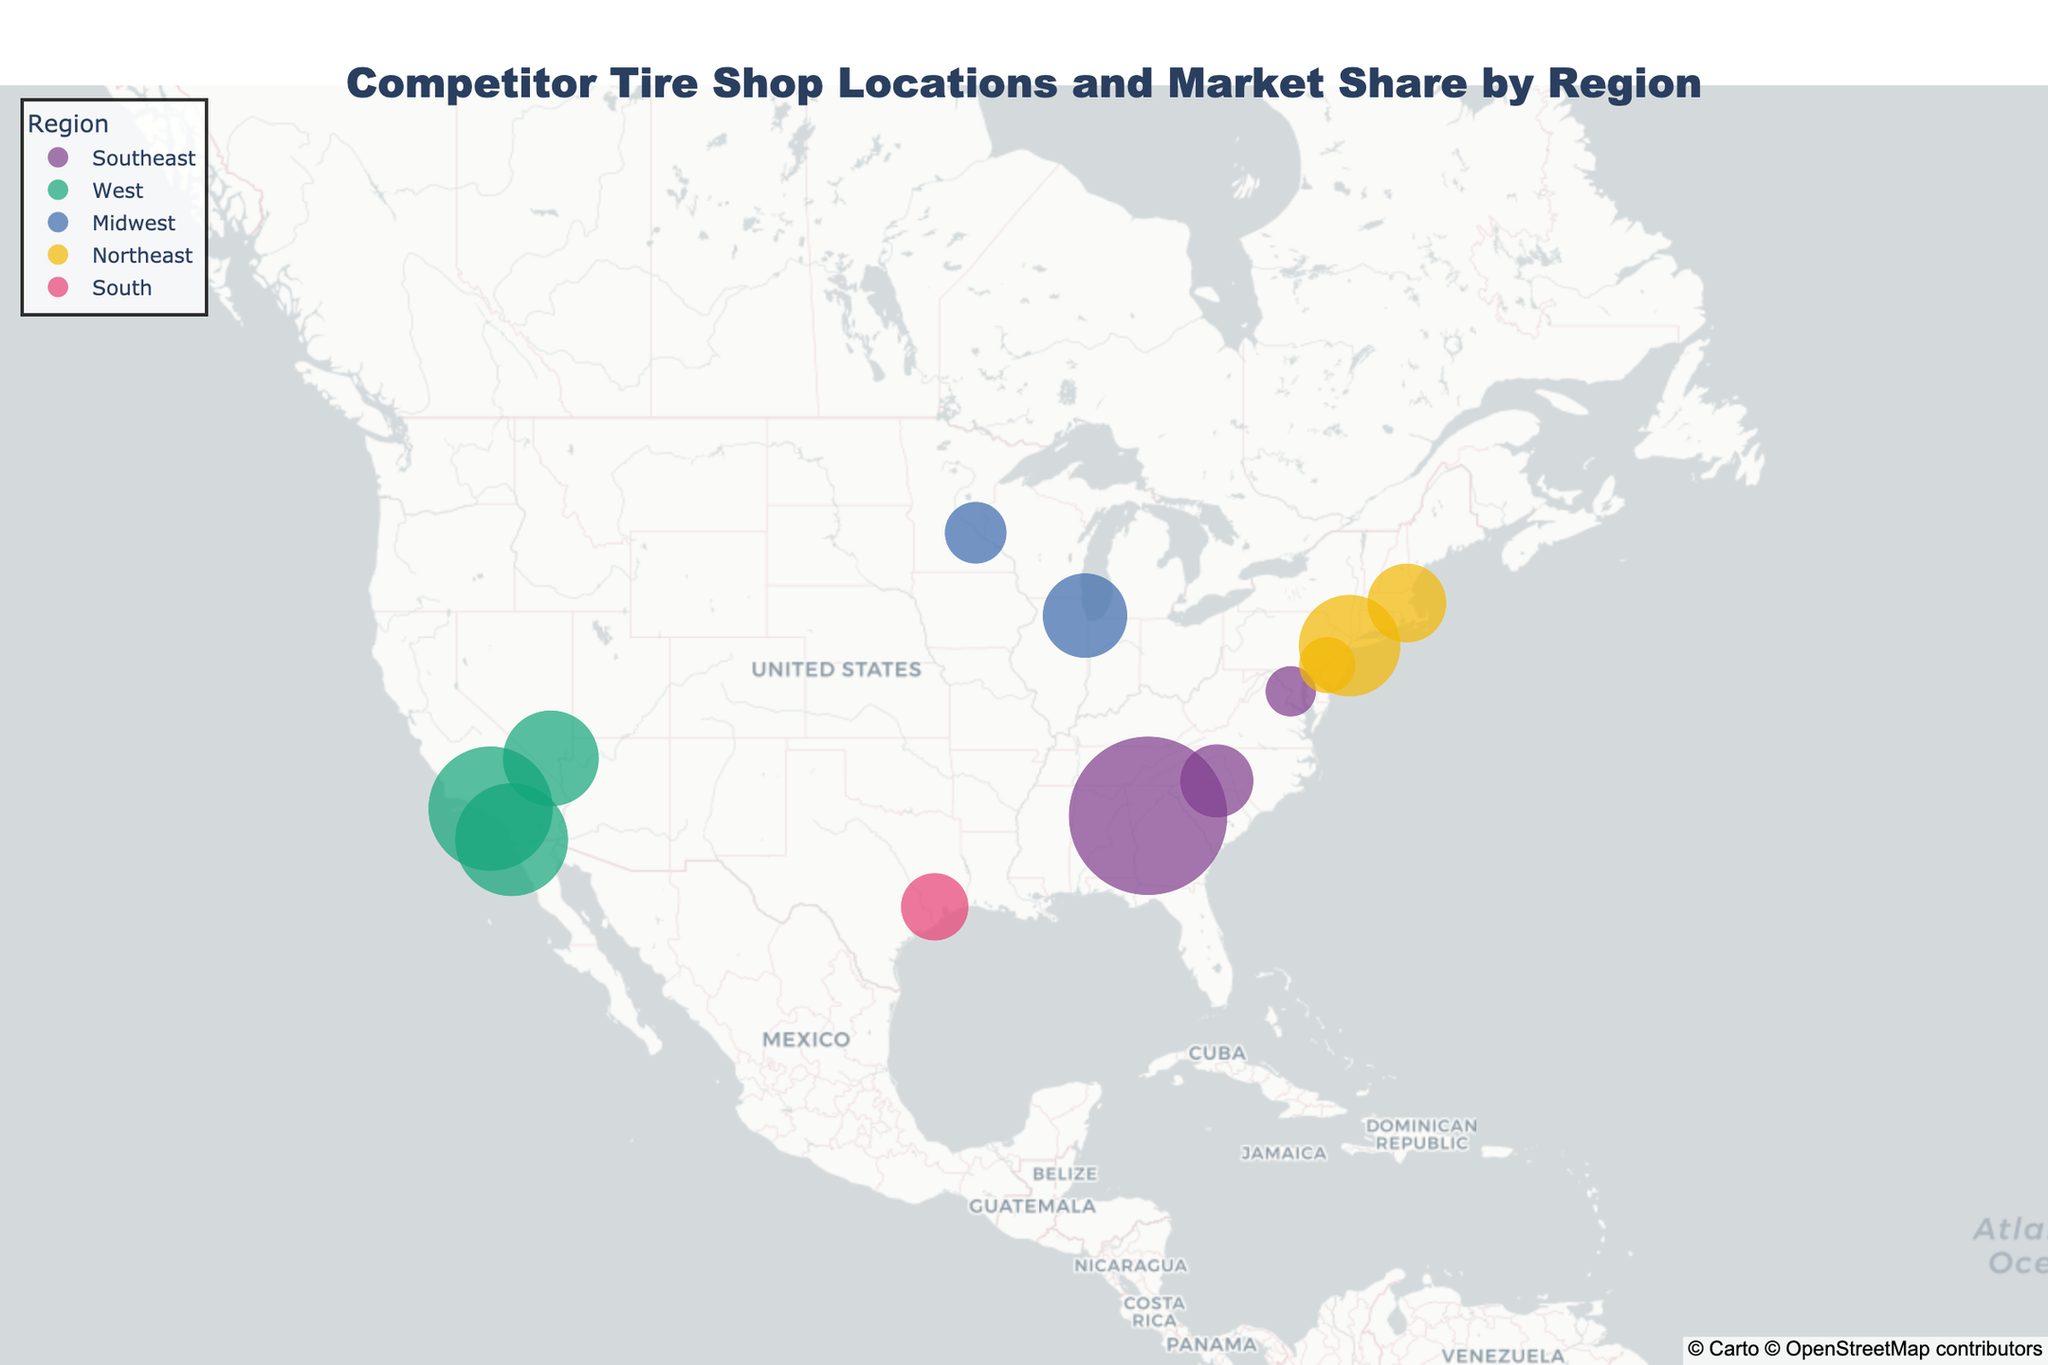How many competitor tire shops are located in the Northeast region? Look at the "Region" colors and identify which ones are labeled as "Northeast." There are three competitors: Town Fair Tire, Mavis Discount Tire, and Sullivan Tire.
Answer: 3 Which competitor has the highest market share in the Southeast? Look at the bubbles in the Southeast region and compare their sizes and market share values. Discount Tire has the highest market share of 28%.
Answer: Discount Tire What is the total market share of tire shops in the Northeast region? Identify the market shares of the competitors in the Northeast: Town Fair Tire (18), Mavis Discount Tire (10), and Sullivan Tire (14). Sum them up: 18 + 10 + 14 = 42.
Answer: 42 Which region has the smallest market share represented on the map? Compare the market shares of all tire shops and identify the smallest one. NTB in the Southeast has a market share of 9%, which is the smallest on the map.
Answer: Southeast How does the market share of Belle Tire in the Midwest compare to that of Tires Plus in the same region? Look at the Midwest region and compare the market shares of Belle Tire (15) and Tires Plus (11). Subtract 11 from 15, the difference is 4. So, Belle Tire's market share is 4% more.
Answer: Belle Tire has 4% more What is the average market share for tire shops in the West region? Identify the market shares of the competitors in the West: America's Tire (22), Les Schwab Tire (20), and Big O Tires (17). Sum them up: 22 + 20 + 17 = 59. Divide by the number of competitors: 59 / 3 ≈ 19.67.
Answer: about 19.67 Which competitor is located in Houston, Texas, and what is its market share? Locate the bubble near Houston, Texas (Latitude 29.7604, Longitude -95.3698) and observe the corresponding hover text. Pep Boys is located there with a market share of 12%.
Answer: Pep Boys, 12% What is the combined market share of tire shops in the Midwest region? Identify the market shares of the competitors in the Midwest: Belle Tire (15) and Tires Plus (11). Sum them up: 15 + 11 = 26.
Answer: 26 In terms of geographic distribution, which region has the most number of competitors? Count the number of competitors in each region based on the color and label: Southeast - 3, West - 3, Midwest - 2, Northeast - 3, South - 1. Multiple regions have three competitors, but Southeast and West are the largest in terms of market distribution.
Answer: Southeast and West Which competitor has the smallest market share in the map and in which region is it located? Look for the smallest bubble on the map and note the corresponding hover text. NTB in the Southeast has the smallest market share of 9%.
Answer: NTB, Southeast 